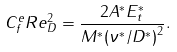<formula> <loc_0><loc_0><loc_500><loc_500>C _ { f } ^ { e } R e ^ { 2 } _ { D } = \frac { 2 A ^ { * } E ^ { * } _ { t } } { M ^ { * } { ( \nu ^ { * } / D ^ { * } ) } ^ { 2 } } .</formula> 